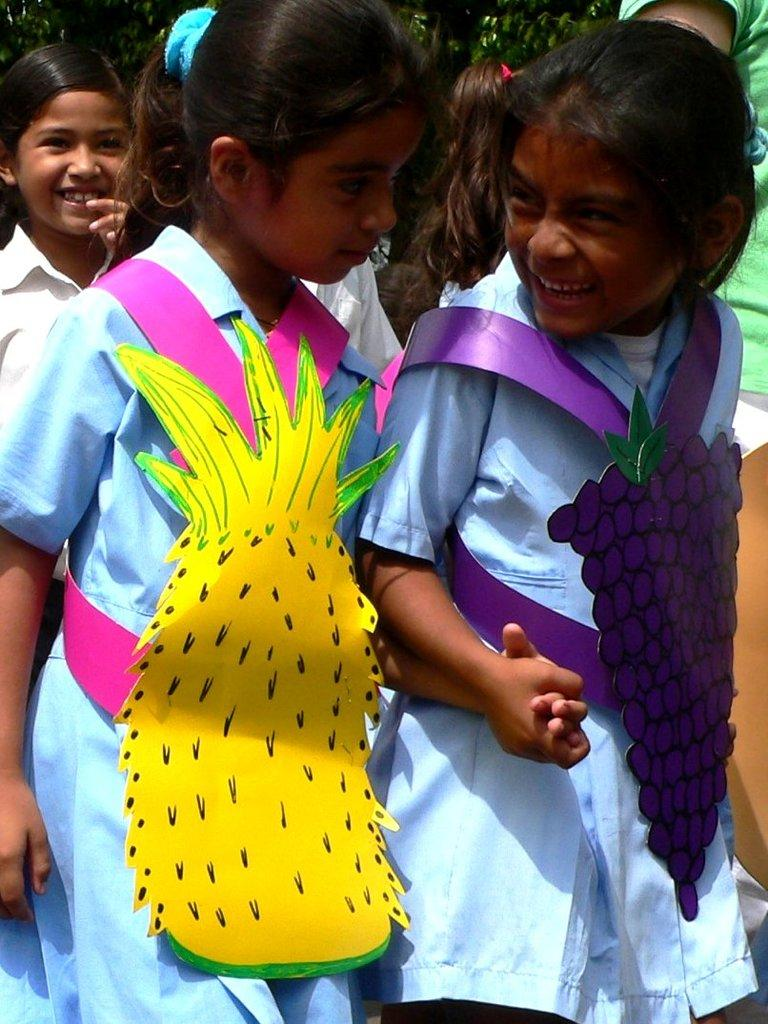What can be seen in the image? There is a group of girls in the image. What are the girls wearing? The girls are wearing uniforms. What other objects or elements are present in the image? There are fruits made of chart and trees in the background of the image. How many mailboxes are visible in the image? There are no mailboxes present in the image. What type of clocks can be seen hanging from the trees in the image? There are no clocks visible in the image, as it features a group of girls, uniforms, fruits made of chart, and trees in the background. 